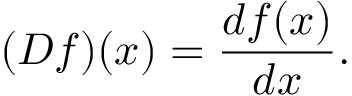<formula> <loc_0><loc_0><loc_500><loc_500>( D f ) ( x ) = { \frac { d f ( x ) } { d x } } .</formula> 